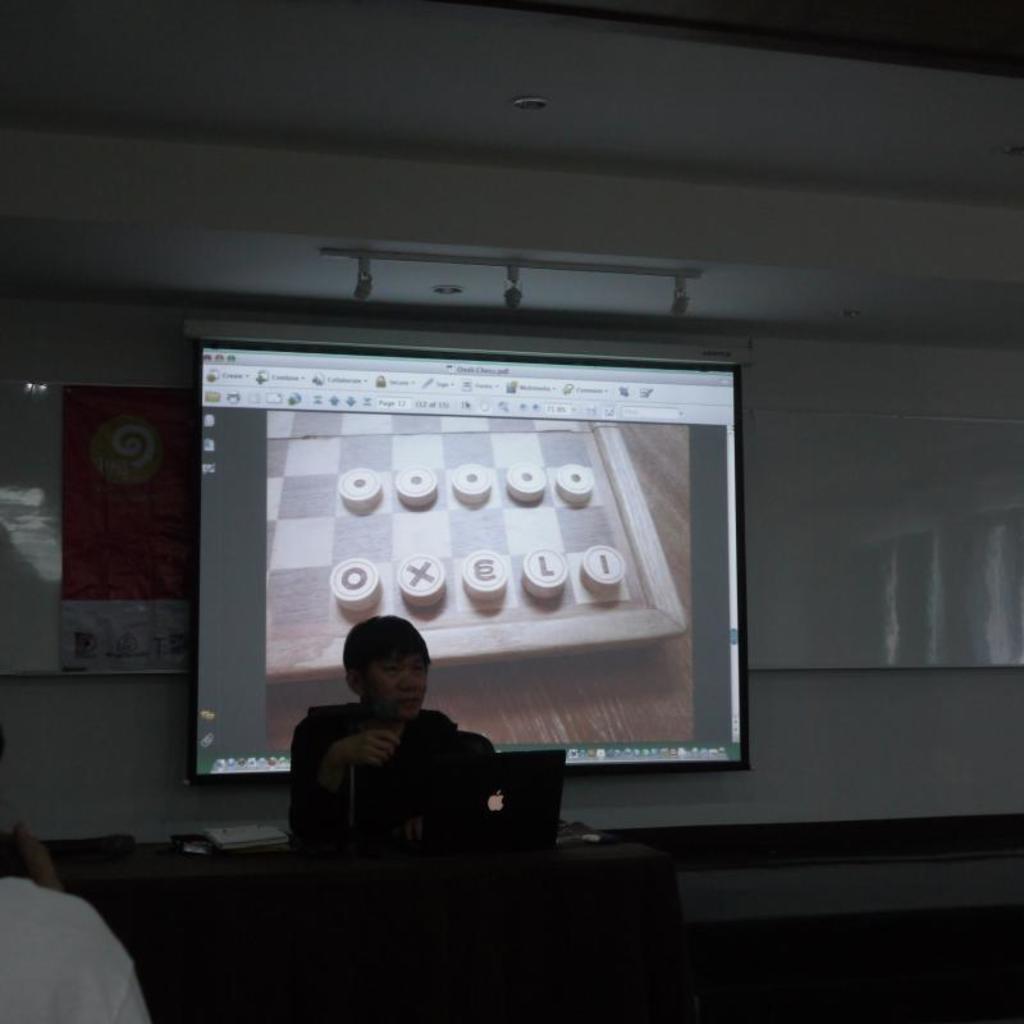Describe this image in one or two sentences. This image consists of a person sitting. In front of him, there is a laptop, on the table. In the background, we can see projector screen on the wall. At the top, there is a roof. On the left, there is a person wearing a white T-shirt. 